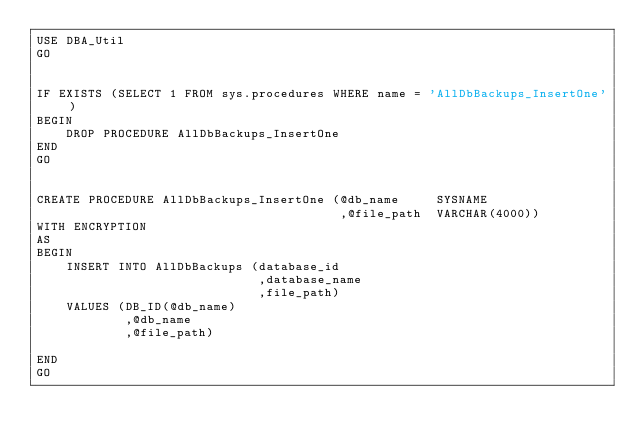<code> <loc_0><loc_0><loc_500><loc_500><_SQL_>USE DBA_Util
GO


IF EXISTS (SELECT 1 FROM sys.procedures WHERE name = 'AllDbBackups_InsertOne')
BEGIN
    DROP PROCEDURE AllDbBackups_InsertOne
END
GO


CREATE PROCEDURE AllDbBackups_InsertOne (@db_name     SYSNAME
                                         ,@file_path  VARCHAR(4000))
WITH ENCRYPTION
AS
BEGIN
    INSERT INTO AllDbBackups (database_id
                              ,database_name
                              ,file_path)
    VALUES (DB_ID(@db_name)
            ,@db_name
            ,@file_path)

END
GO</code> 